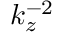Convert formula to latex. <formula><loc_0><loc_0><loc_500><loc_500>k _ { z } ^ { - 2 }</formula> 